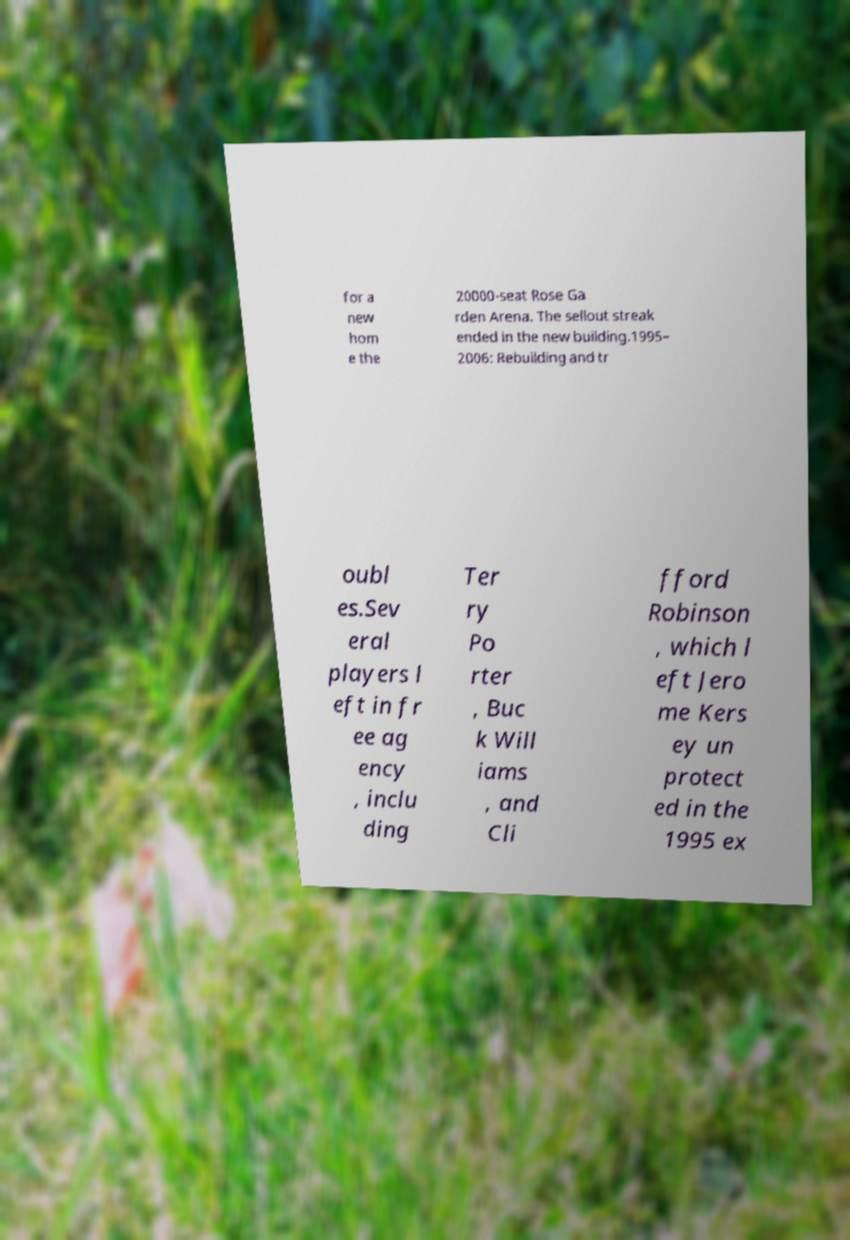For documentation purposes, I need the text within this image transcribed. Could you provide that? for a new hom e the 20000-seat Rose Ga rden Arena. The sellout streak ended in the new building.1995– 2006: Rebuilding and tr oubl es.Sev eral players l eft in fr ee ag ency , inclu ding Ter ry Po rter , Buc k Will iams , and Cli fford Robinson , which l eft Jero me Kers ey un protect ed in the 1995 ex 